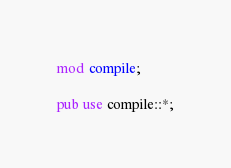<code> <loc_0><loc_0><loc_500><loc_500><_Rust_>mod compile;

pub use compile::*;
</code> 